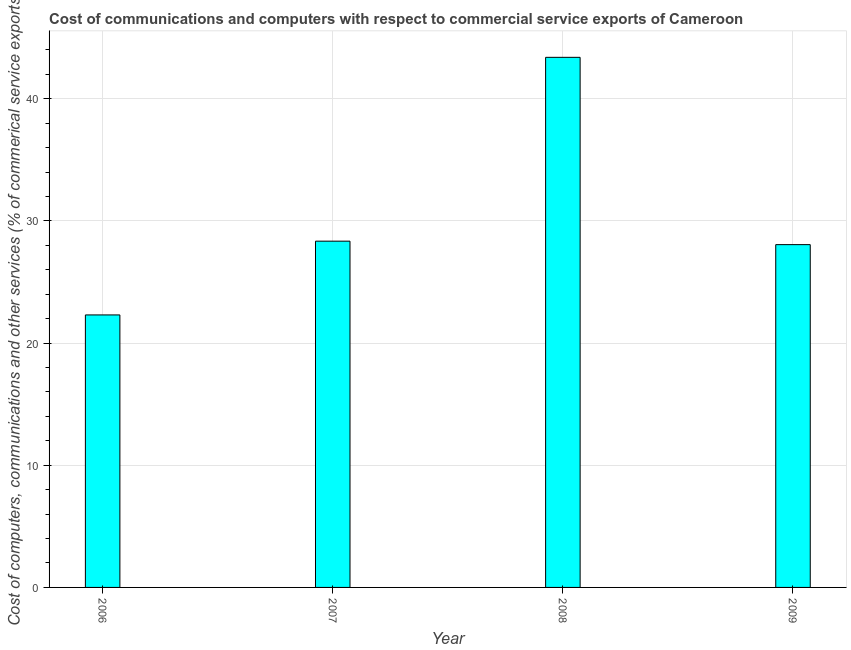Does the graph contain grids?
Make the answer very short. Yes. What is the title of the graph?
Ensure brevity in your answer.  Cost of communications and computers with respect to commercial service exports of Cameroon. What is the label or title of the Y-axis?
Your response must be concise. Cost of computers, communications and other services (% of commerical service exports). What is the  computer and other services in 2006?
Your answer should be very brief. 22.31. Across all years, what is the maximum  computer and other services?
Offer a terse response. 43.4. Across all years, what is the minimum cost of communications?
Offer a terse response. 22.31. In which year was the cost of communications maximum?
Ensure brevity in your answer.  2008. What is the sum of the  computer and other services?
Provide a succinct answer. 122.12. What is the difference between the  computer and other services in 2007 and 2009?
Keep it short and to the point. 0.28. What is the average  computer and other services per year?
Your answer should be very brief. 30.53. What is the median cost of communications?
Offer a very short reply. 28.21. In how many years, is the  computer and other services greater than 10 %?
Your answer should be very brief. 4. What is the ratio of the  computer and other services in 2006 to that in 2009?
Your answer should be compact. 0.8. Is the  computer and other services in 2006 less than that in 2008?
Keep it short and to the point. Yes. Is the difference between the cost of communications in 2006 and 2007 greater than the difference between any two years?
Provide a succinct answer. No. What is the difference between the highest and the second highest cost of communications?
Make the answer very short. 15.05. What is the difference between the highest and the lowest cost of communications?
Your response must be concise. 21.09. In how many years, is the  computer and other services greater than the average  computer and other services taken over all years?
Give a very brief answer. 1. How many years are there in the graph?
Keep it short and to the point. 4. Are the values on the major ticks of Y-axis written in scientific E-notation?
Ensure brevity in your answer.  No. What is the Cost of computers, communications and other services (% of commerical service exports) in 2006?
Make the answer very short. 22.31. What is the Cost of computers, communications and other services (% of commerical service exports) in 2007?
Make the answer very short. 28.35. What is the Cost of computers, communications and other services (% of commerical service exports) in 2008?
Offer a terse response. 43.4. What is the Cost of computers, communications and other services (% of commerical service exports) of 2009?
Ensure brevity in your answer.  28.06. What is the difference between the Cost of computers, communications and other services (% of commerical service exports) in 2006 and 2007?
Your response must be concise. -6.04. What is the difference between the Cost of computers, communications and other services (% of commerical service exports) in 2006 and 2008?
Provide a short and direct response. -21.09. What is the difference between the Cost of computers, communications and other services (% of commerical service exports) in 2006 and 2009?
Provide a succinct answer. -5.75. What is the difference between the Cost of computers, communications and other services (% of commerical service exports) in 2007 and 2008?
Provide a short and direct response. -15.05. What is the difference between the Cost of computers, communications and other services (% of commerical service exports) in 2007 and 2009?
Make the answer very short. 0.28. What is the difference between the Cost of computers, communications and other services (% of commerical service exports) in 2008 and 2009?
Provide a short and direct response. 15.34. What is the ratio of the Cost of computers, communications and other services (% of commerical service exports) in 2006 to that in 2007?
Provide a short and direct response. 0.79. What is the ratio of the Cost of computers, communications and other services (% of commerical service exports) in 2006 to that in 2008?
Provide a succinct answer. 0.51. What is the ratio of the Cost of computers, communications and other services (% of commerical service exports) in 2006 to that in 2009?
Provide a short and direct response. 0.8. What is the ratio of the Cost of computers, communications and other services (% of commerical service exports) in 2007 to that in 2008?
Offer a terse response. 0.65. What is the ratio of the Cost of computers, communications and other services (% of commerical service exports) in 2008 to that in 2009?
Offer a terse response. 1.55. 